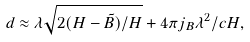Convert formula to latex. <formula><loc_0><loc_0><loc_500><loc_500>d \approx \lambda \sqrt { { 2 ( H - \tilde { B } ) / H } } + 4 \pi j _ { B } \lambda ^ { 2 } / c H ,</formula> 